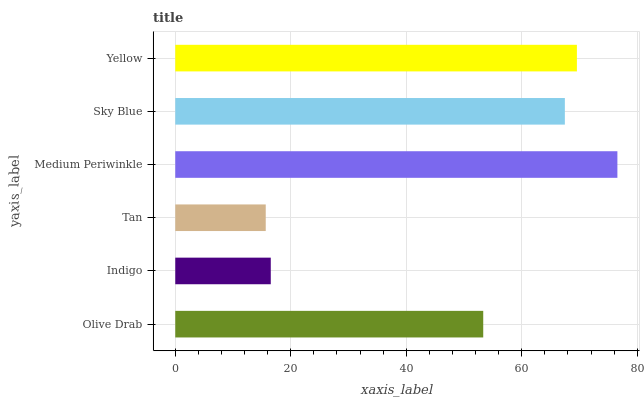Is Tan the minimum?
Answer yes or no. Yes. Is Medium Periwinkle the maximum?
Answer yes or no. Yes. Is Indigo the minimum?
Answer yes or no. No. Is Indigo the maximum?
Answer yes or no. No. Is Olive Drab greater than Indigo?
Answer yes or no. Yes. Is Indigo less than Olive Drab?
Answer yes or no. Yes. Is Indigo greater than Olive Drab?
Answer yes or no. No. Is Olive Drab less than Indigo?
Answer yes or no. No. Is Sky Blue the high median?
Answer yes or no. Yes. Is Olive Drab the low median?
Answer yes or no. Yes. Is Indigo the high median?
Answer yes or no. No. Is Tan the low median?
Answer yes or no. No. 